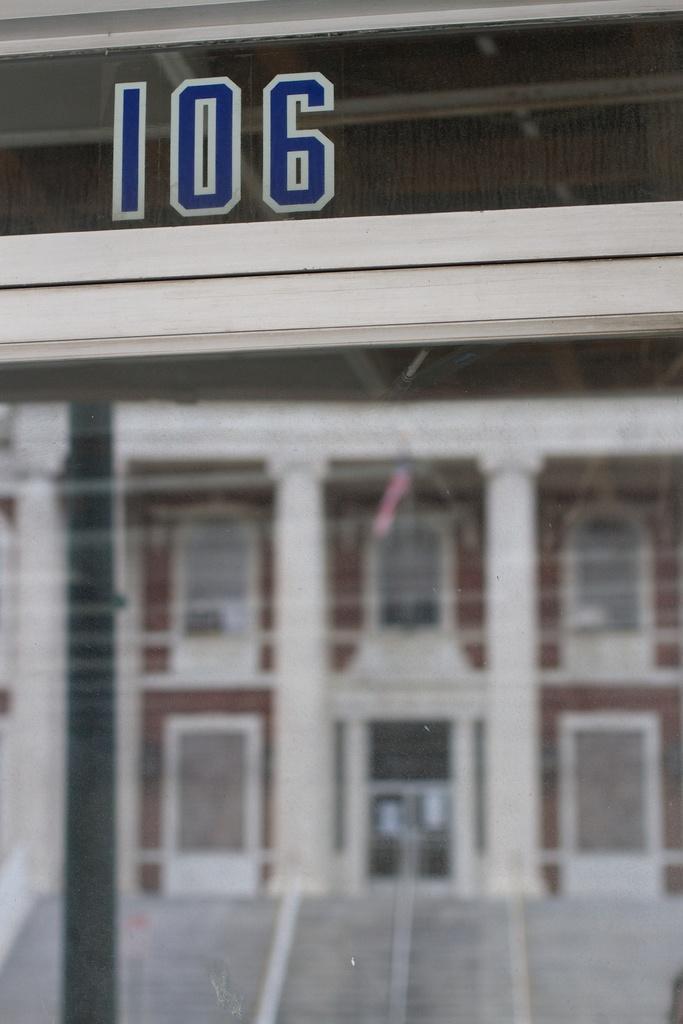In one or two sentences, can you explain what this image depicts? In this image in the front there is a mirror and on the top of the mirror there is a number written on it. Behind the mirror there is a building which is white in colour and there are red coloured borders on the building. 